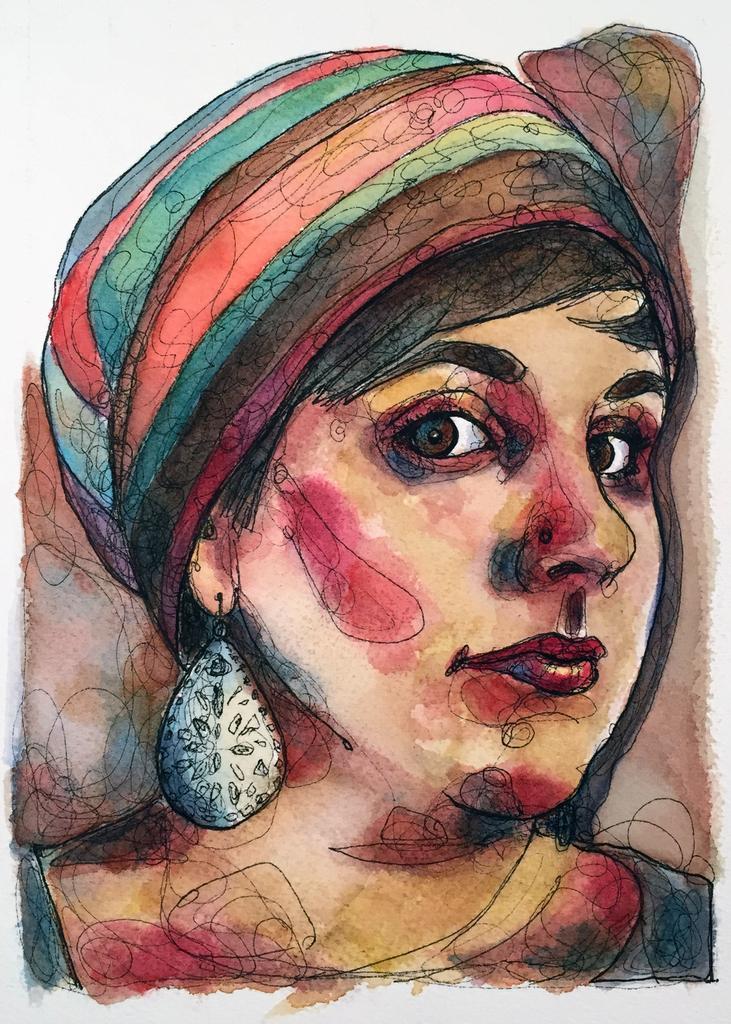How would you summarize this image in a sentence or two? This is a picture of a colorful painting. In this picture we can see a woman. 